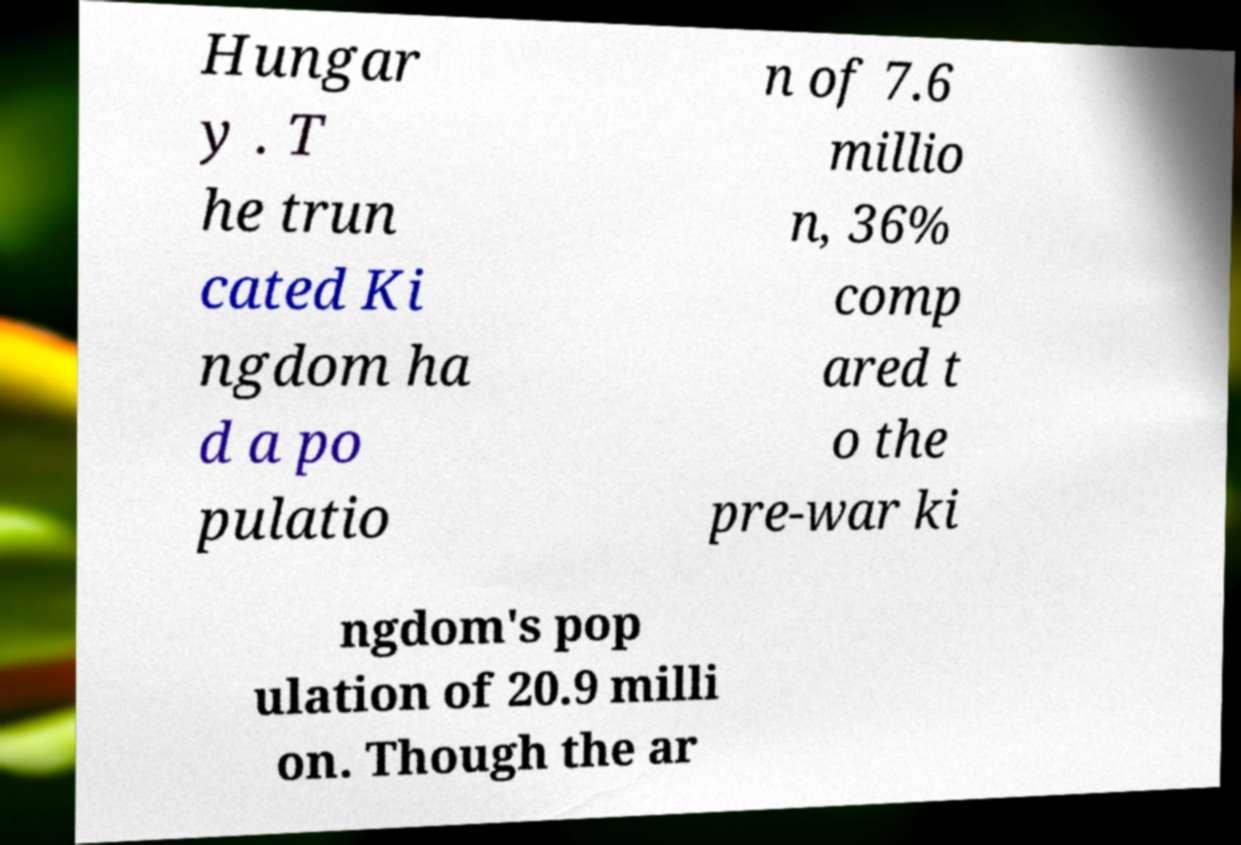Please read and relay the text visible in this image. What does it say? Hungar y . T he trun cated Ki ngdom ha d a po pulatio n of 7.6 millio n, 36% comp ared t o the pre-war ki ngdom's pop ulation of 20.9 milli on. Though the ar 